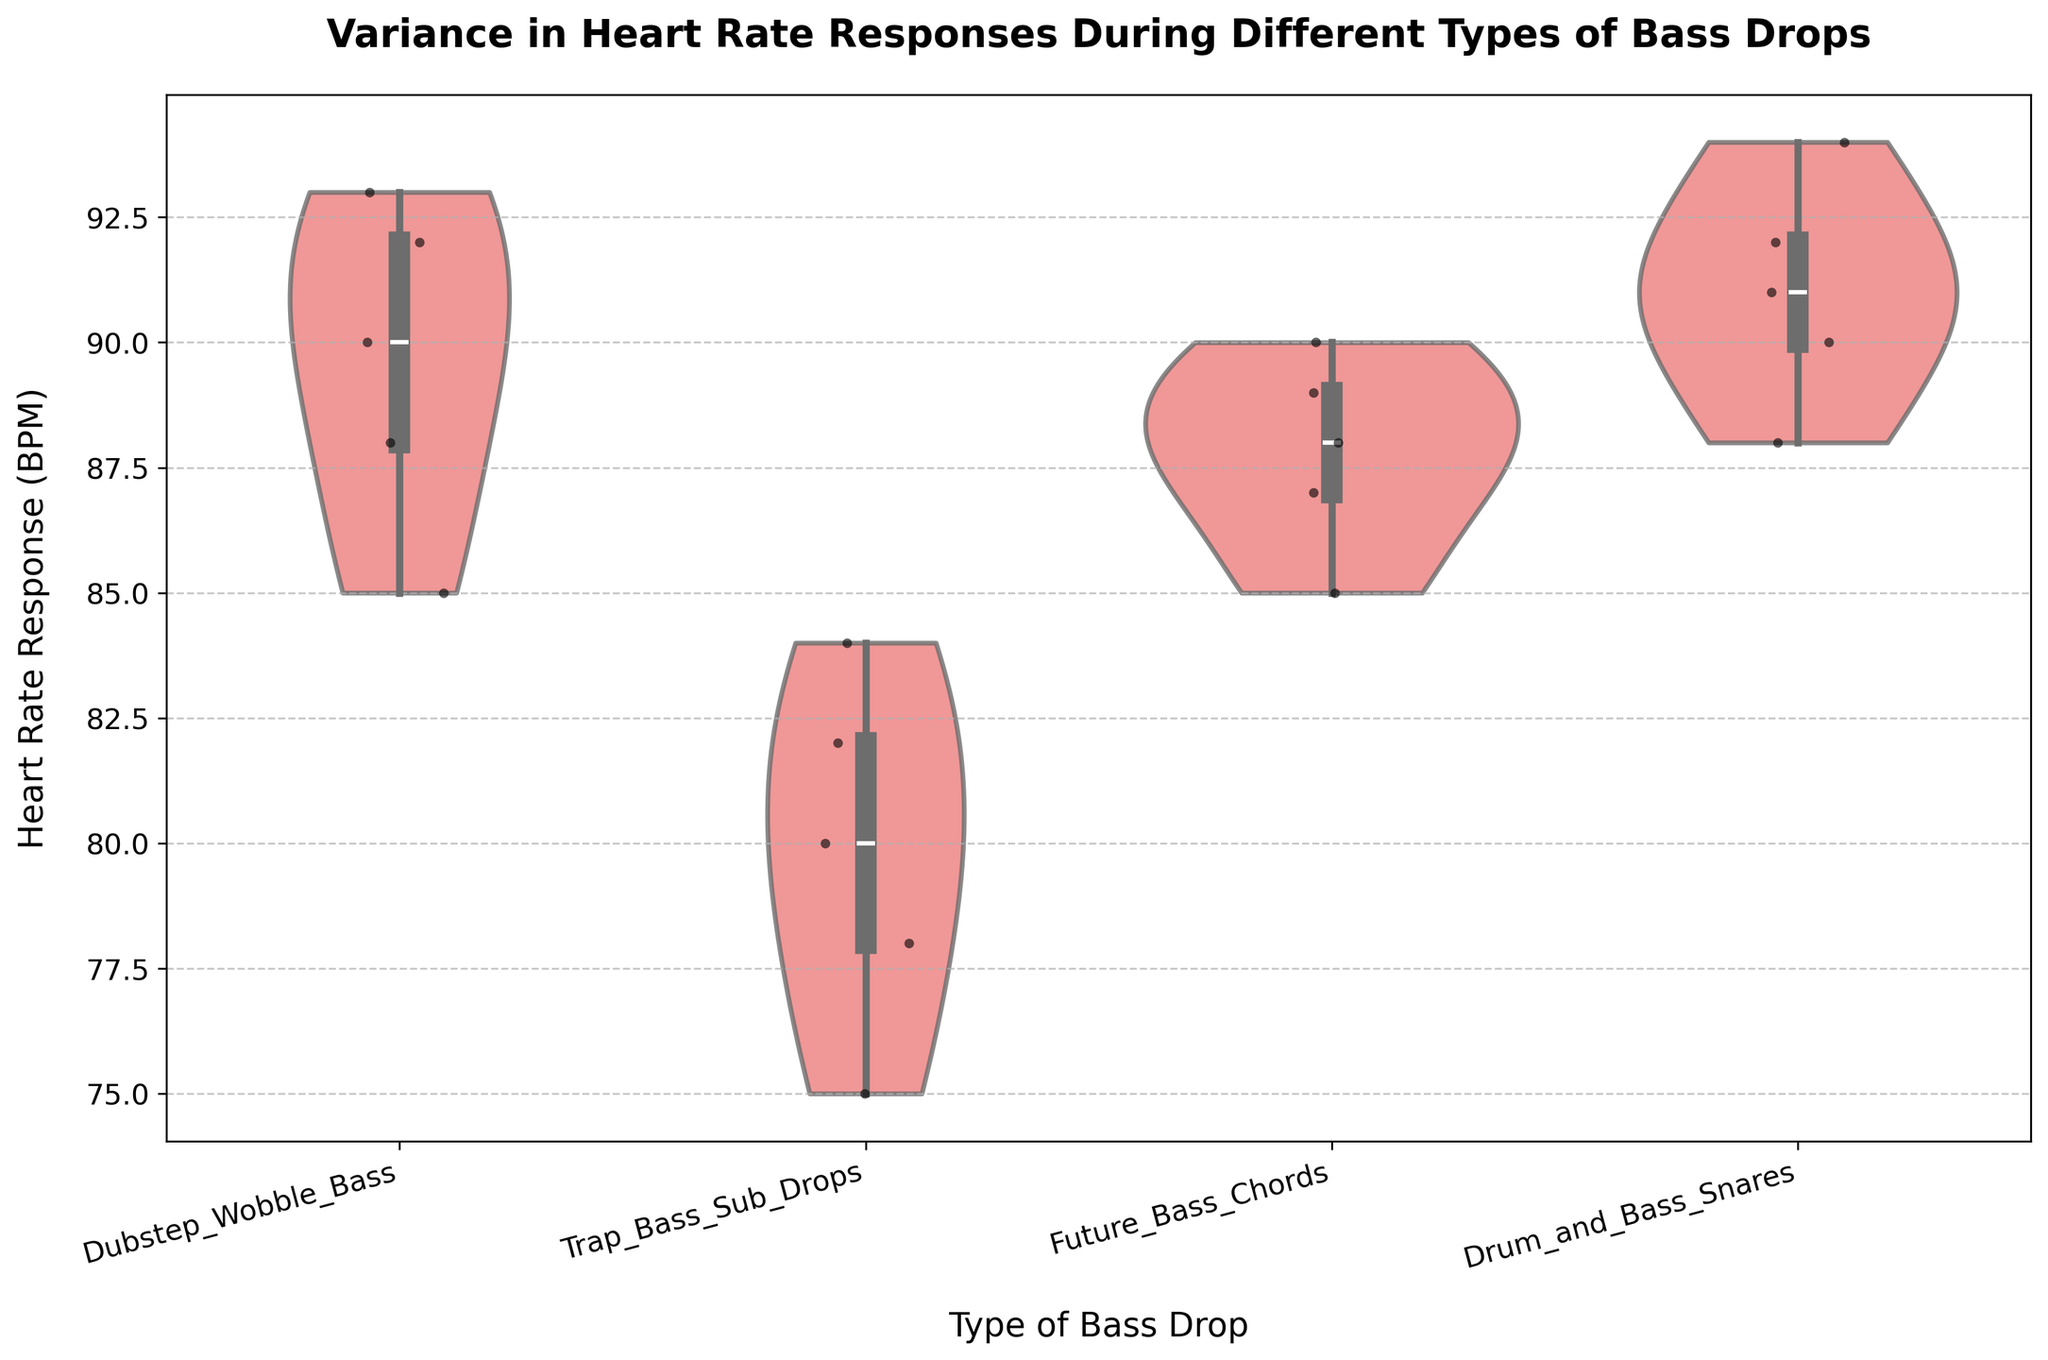What is the title of the plot? The title of the plot is displayed prominently at the top.
Answer: Variance in Heart Rate Responses During Different Types of Bass Drops What are the four types of bass drops shown in the plot? The x-axis labels show the names of the bass drops.
Answer: Dubstep Wobble Bass, Trap Bass Sub Drops, Future Bass Chords, Drum and Bass Snares Which type of bass drop has the highest median heart rate response? The median is shown as a horizontal line within each violin.
Answer: Drum and Bass Snares How does the average heart rate response for Dubstep Wobble Bass compare to Trap Bass Sub Drops? To find the average, sum the heart rate responses for each type and divide by the number of data points.
Answer: Dubstep Wobble Bass has a higher average heart rate response Which type of bass drop shows the widest range in heart rate responses? The range is indicated by the width and spread of the violin plot.
Answer: Dubstep Wobble Bass What is the heart rate response range for Future Bass Chords? Find the minimum and maximum data points within the violin plot for Future Bass Chords.
Answer: 85 to 90 BPM Do any bass drop types have any data points significantly far from the median, indicating potential outliers? Look for data points outside the range of the main body of the violin plot.
Answer: Trap Bass Sub Drops Compare the variability in heart rate responses of Dubstep Wobble Bass to Drum and Bass Snares. Variability is indicated by the shape and spread of the violin plots.
Answer: Dubstep Wobble Bass has more variability How many heart rate responses were recorded for each type of bass drop? Count the number of jittered points within each violin plot.
Answer: 5 for each type Which type of bass drop has the highest maximum heart rate response? The maximum heart rate response is indicated by the topmost point of the violin plot.
Answer: Dubstep Wobble Bass 